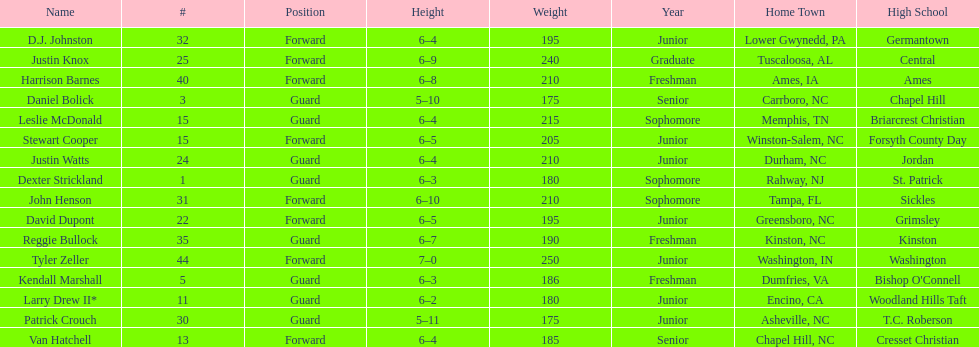Parse the table in full. {'header': ['Name', '#', 'Position', 'Height', 'Weight', 'Year', 'Home Town', 'High School'], 'rows': [['D.J. Johnston', '32', 'Forward', '6–4', '195', 'Junior', 'Lower Gwynedd, PA', 'Germantown'], ['Justin Knox', '25', 'Forward', '6–9', '240', 'Graduate', 'Tuscaloosa, AL', 'Central'], ['Harrison Barnes', '40', 'Forward', '6–8', '210', 'Freshman', 'Ames, IA', 'Ames'], ['Daniel Bolick', '3', 'Guard', '5–10', '175', 'Senior', 'Carrboro, NC', 'Chapel Hill'], ['Leslie McDonald', '15', 'Guard', '6–4', '215', 'Sophomore', 'Memphis, TN', 'Briarcrest Christian'], ['Stewart Cooper', '15', 'Forward', '6–5', '205', 'Junior', 'Winston-Salem, NC', 'Forsyth County Day'], ['Justin Watts', '24', 'Guard', '6–4', '210', 'Junior', 'Durham, NC', 'Jordan'], ['Dexter Strickland', '1', 'Guard', '6–3', '180', 'Sophomore', 'Rahway, NJ', 'St. Patrick'], ['John Henson', '31', 'Forward', '6–10', '210', 'Sophomore', 'Tampa, FL', 'Sickles'], ['David Dupont', '22', 'Forward', '6–5', '195', 'Junior', 'Greensboro, NC', 'Grimsley'], ['Reggie Bullock', '35', 'Guard', '6–7', '190', 'Freshman', 'Kinston, NC', 'Kinston'], ['Tyler Zeller', '44', 'Forward', '7–0', '250', 'Junior', 'Washington, IN', 'Washington'], ['Kendall Marshall', '5', 'Guard', '6–3', '186', 'Freshman', 'Dumfries, VA', "Bishop O'Connell"], ['Larry Drew II*', '11', 'Guard', '6–2', '180', 'Junior', 'Encino, CA', 'Woodland Hills Taft'], ['Patrick Crouch', '30', 'Guard', '5–11', '175', 'Junior', 'Asheville, NC', 'T.C. Roberson'], ['Van Hatchell', '13', 'Forward', '6–4', '185', 'Senior', 'Chapel Hill, NC', 'Cresset Christian']]} Total number of players whose home town was in north carolina (nc) 7. 